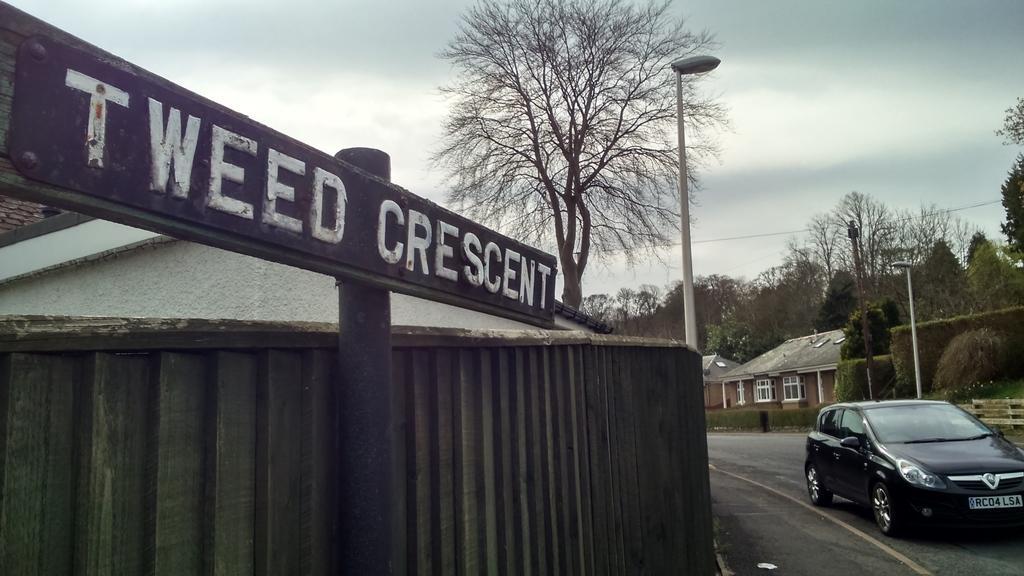Can you describe this image briefly? This picture shows a car moving on the road and we see few trees and few houses and couple of pole lights and we see a name board to the pole and a blue cloudy sky. 